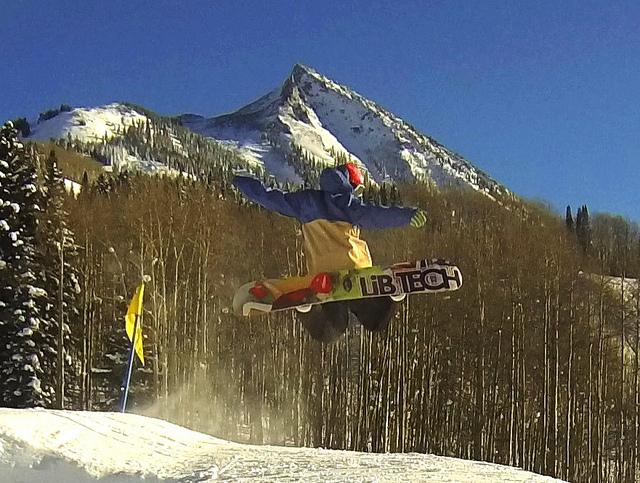What is the person doing in this picture?
Quick response, please. Snowboarding. Would you ever try this?
Keep it brief. No. What is the person wearing on their feet?
Concise answer only. Snowboard. 